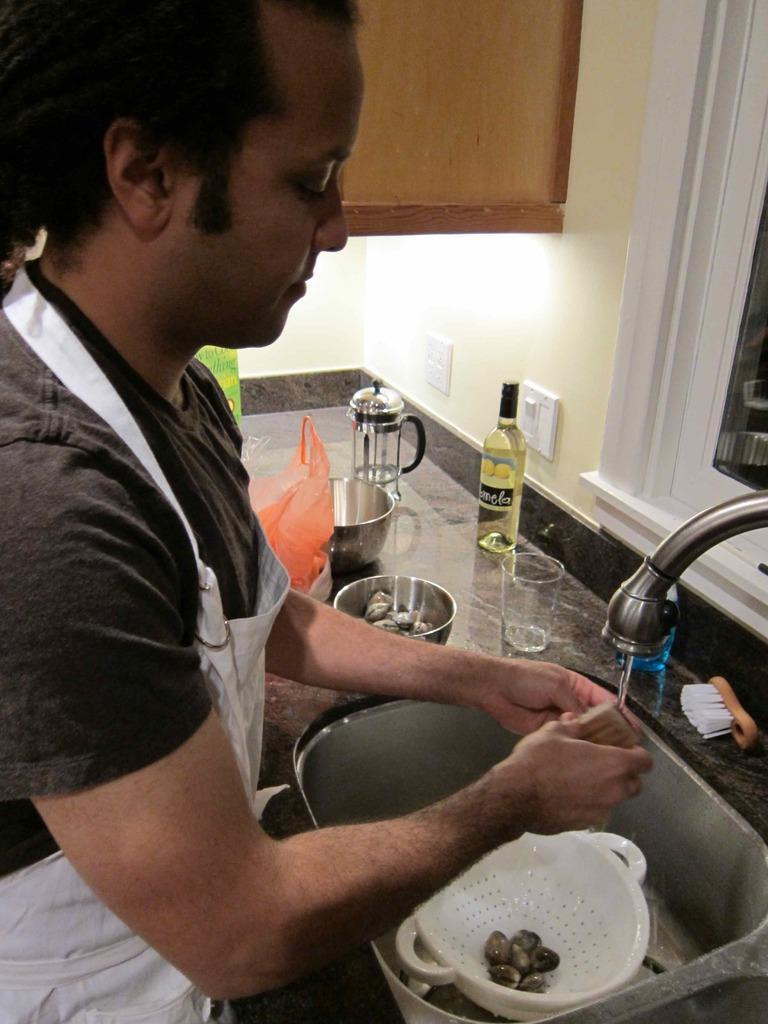Please provide a concise description of this image. In the picture we can see a person wearing black color T-shirt, also wearing white color chef coat, washing some objects which are in wash basin and there are some glasses, bottles and some other utensils and in the background of the picture there is cupboard, there is a wall, on right side of the picture there is a window. 